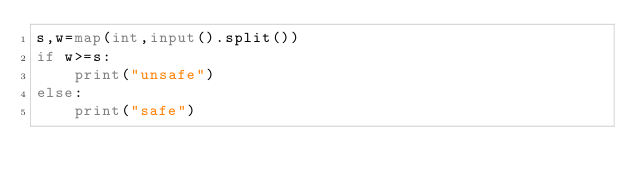<code> <loc_0><loc_0><loc_500><loc_500><_Python_>s,w=map(int,input().split())
if w>=s:
    print("unsafe")
else:
    print("safe")
</code> 